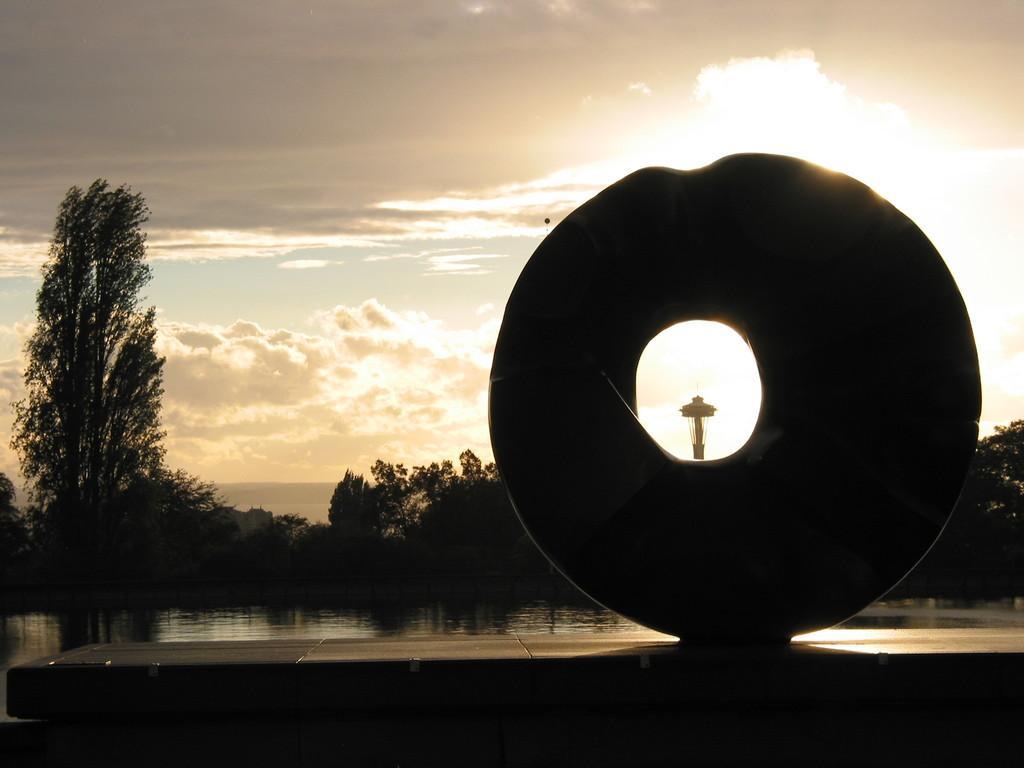Please provide a concise description of this image. In this image we can see the water, few trees, a huge donut shaped structure. In the background there is the sky. 